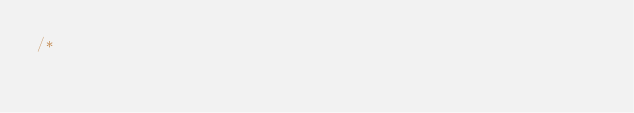Convert code to text. <code><loc_0><loc_0><loc_500><loc_500><_ObjectiveC_>/*</code> 